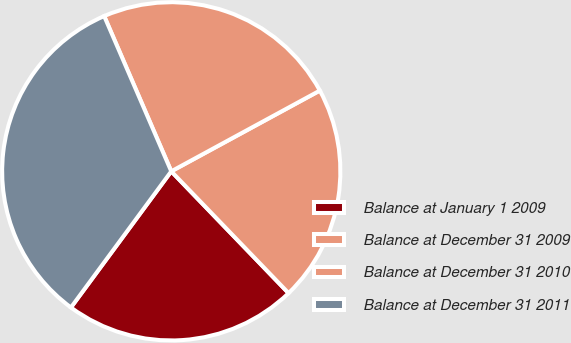Convert chart to OTSL. <chart><loc_0><loc_0><loc_500><loc_500><pie_chart><fcel>Balance at January 1 2009<fcel>Balance at December 31 2009<fcel>Balance at December 31 2010<fcel>Balance at December 31 2011<nl><fcel>22.31%<fcel>20.72%<fcel>23.57%<fcel>33.4%<nl></chart> 